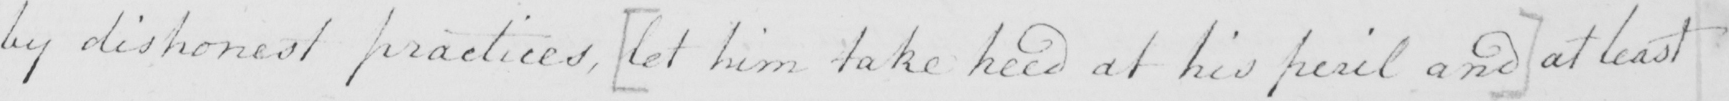What is written in this line of handwriting? by dishonest practices ,  [ let him take heed at his peril and ]  at least 